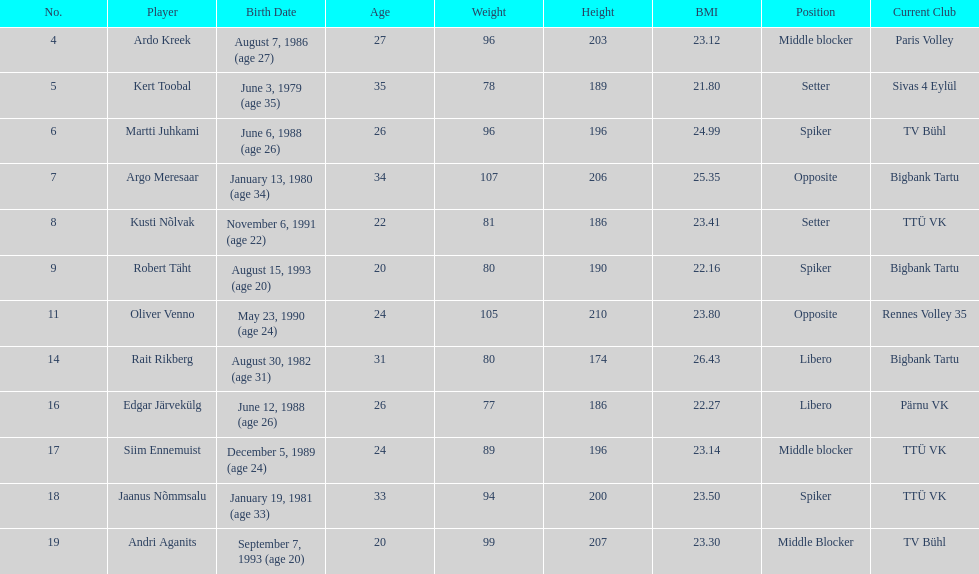How many players are middle blockers? 3. 